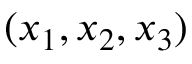Convert formula to latex. <formula><loc_0><loc_0><loc_500><loc_500>( x _ { 1 } , x _ { 2 } , x _ { 3 } )</formula> 